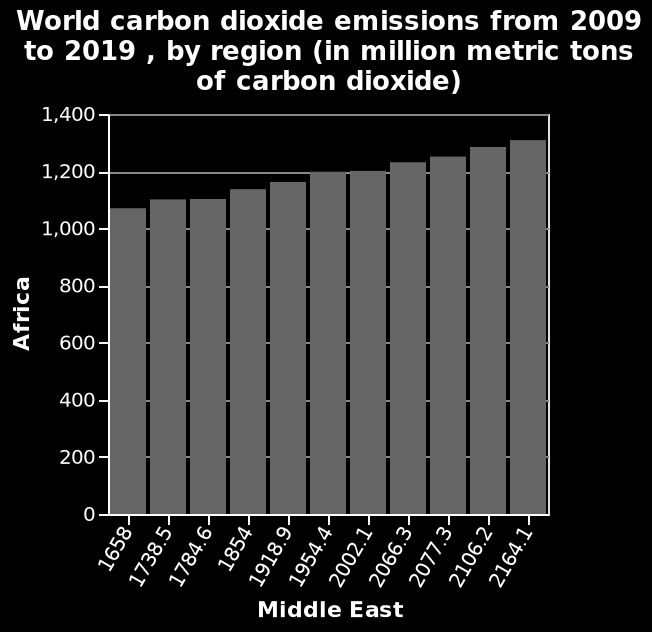<image>
please summary the statistics and relations of the chart I am not able to provide a textual description because there is missing information. please describe the details of the chart Here a is a bar chart titled World carbon dioxide emissions from 2009 to 2019 , by region (in million metric tons of carbon dioxide). The y-axis shows Africa using linear scale from 0 to 1,400 while the x-axis measures Middle East with scale with a minimum of 1658 and a maximum of 2164.1. What does the x-axis measure on the bar chart? The x-axis measures Middle East, with a minimum value of 1658 and a maximum value of 2164.1. Does the x-axis measure Middle East with a minimum value of 2164.1 and a maximum value of 1658? No.The x-axis measures Middle East, with a minimum value of 1658 and a maximum value of 2164.1. 